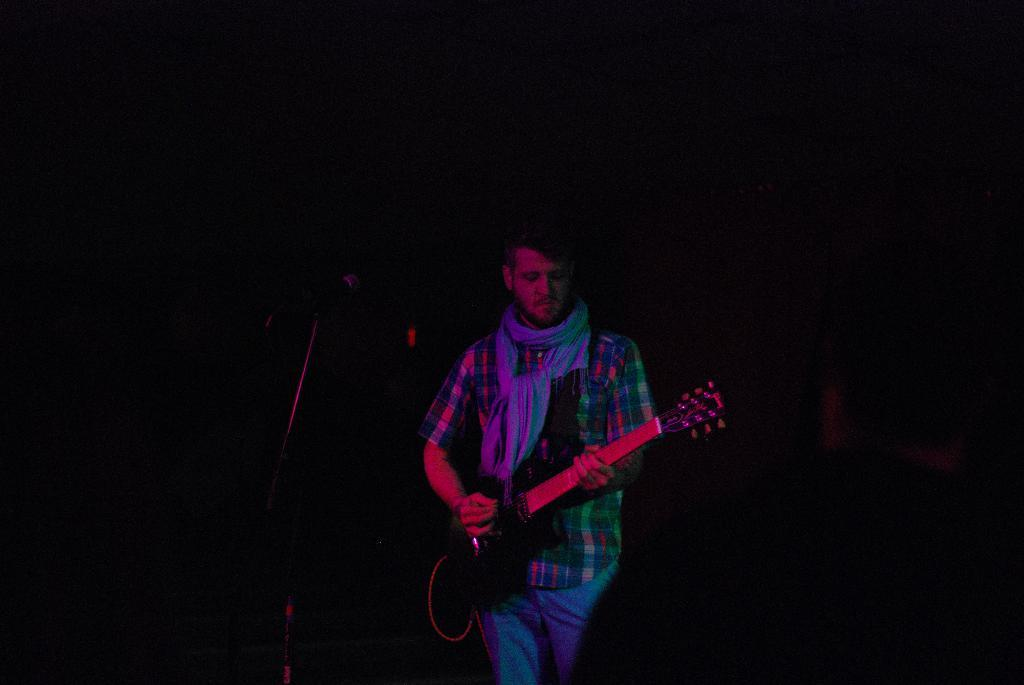What is the main subject of the image? There is a man in the image. What is the man doing in the image? The man is standing and playing the guitar. What object is the man holding in his hand? The man is holding a guitar in his hand. What object is in front of the man? There is a microphone in front of the man. How would you describe the lighting in the image? The image appears to be dark. What book is the man reading while playing the guitar in the image? There is no book present in the image; the man is playing the guitar without any visible reading material. 